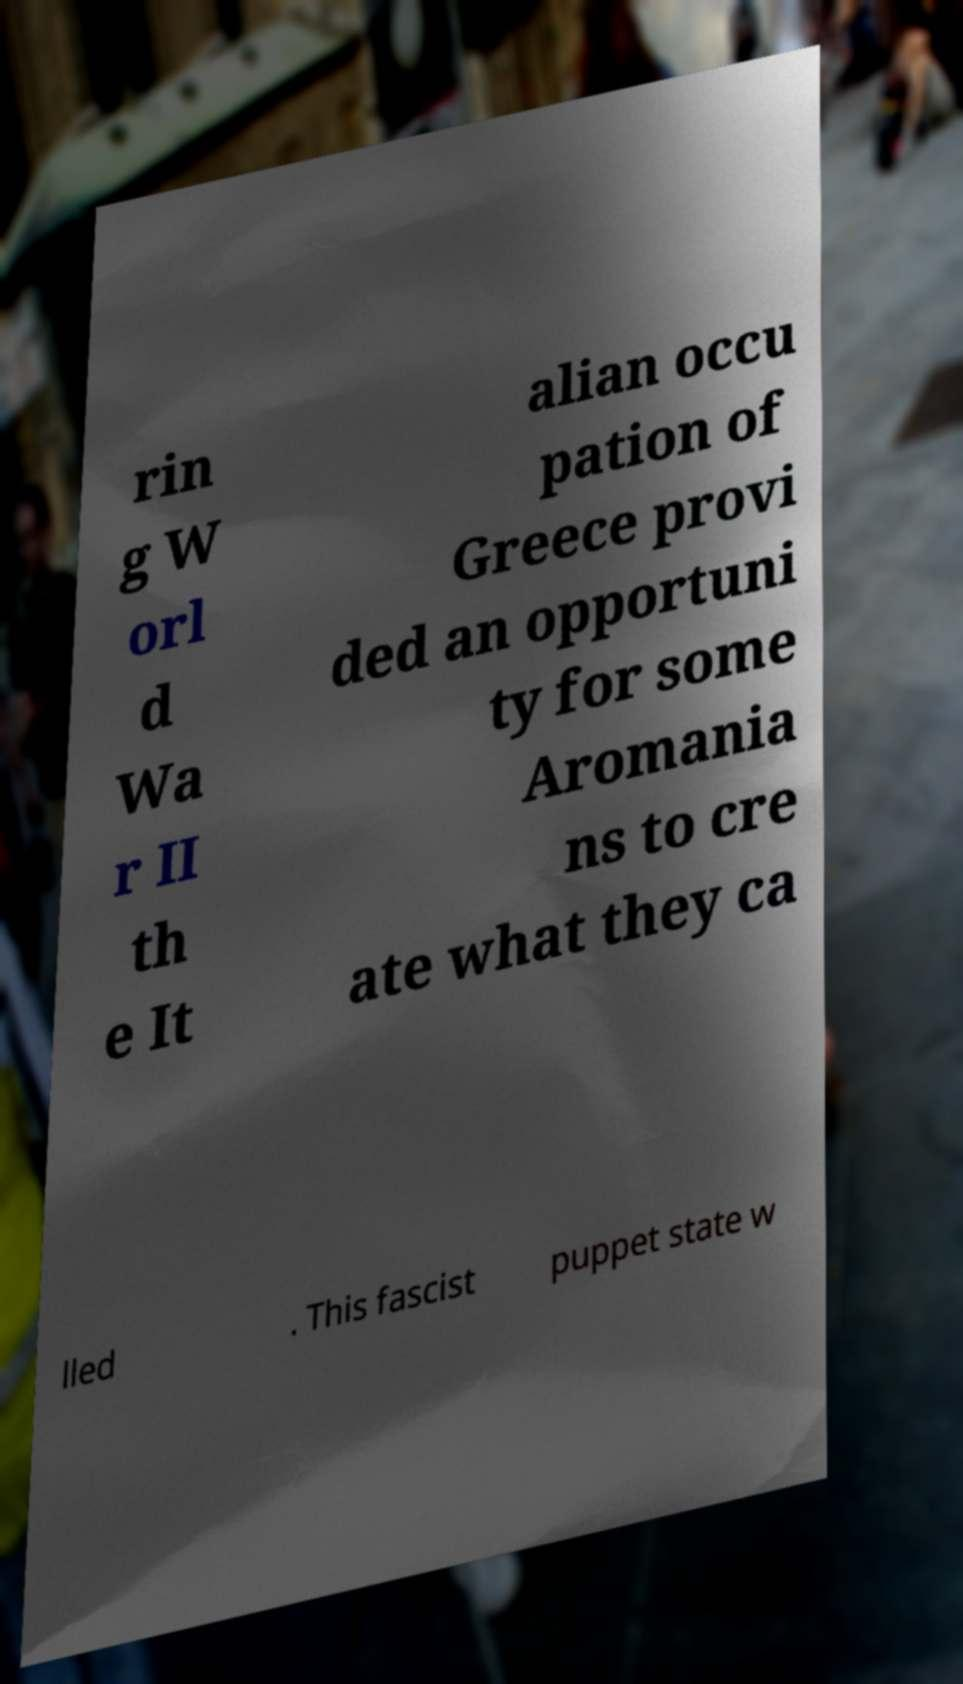For documentation purposes, I need the text within this image transcribed. Could you provide that? rin g W orl d Wa r II th e It alian occu pation of Greece provi ded an opportuni ty for some Aromania ns to cre ate what they ca lled . This fascist puppet state w 